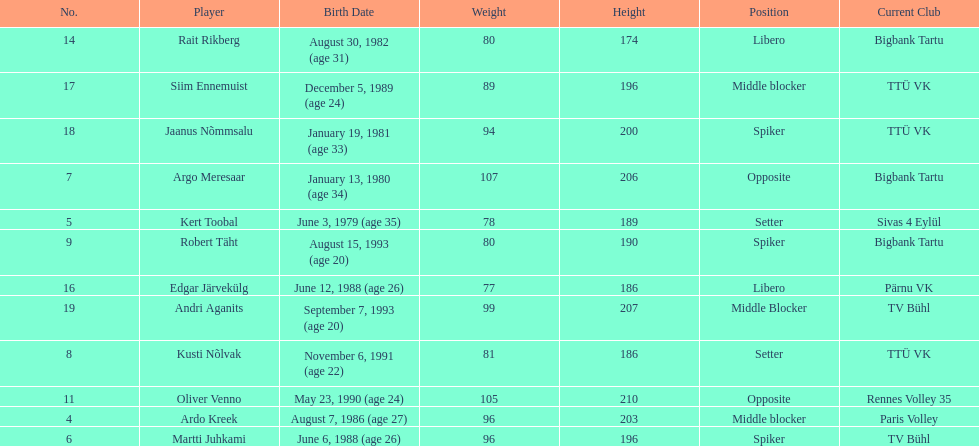Who is the tallest member of estonia's men's national volleyball team? Oliver Venno. 